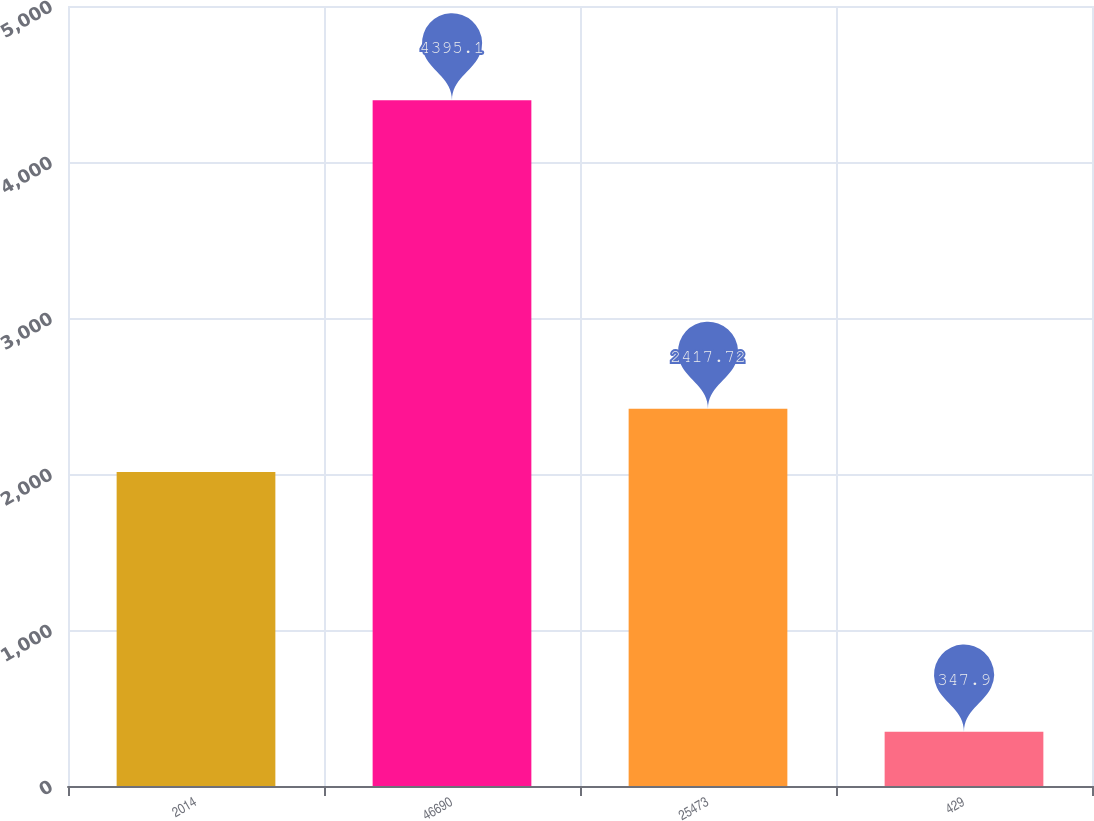Convert chart. <chart><loc_0><loc_0><loc_500><loc_500><bar_chart><fcel>2014<fcel>46690<fcel>25473<fcel>429<nl><fcel>2013<fcel>4395.1<fcel>2417.72<fcel>347.9<nl></chart> 